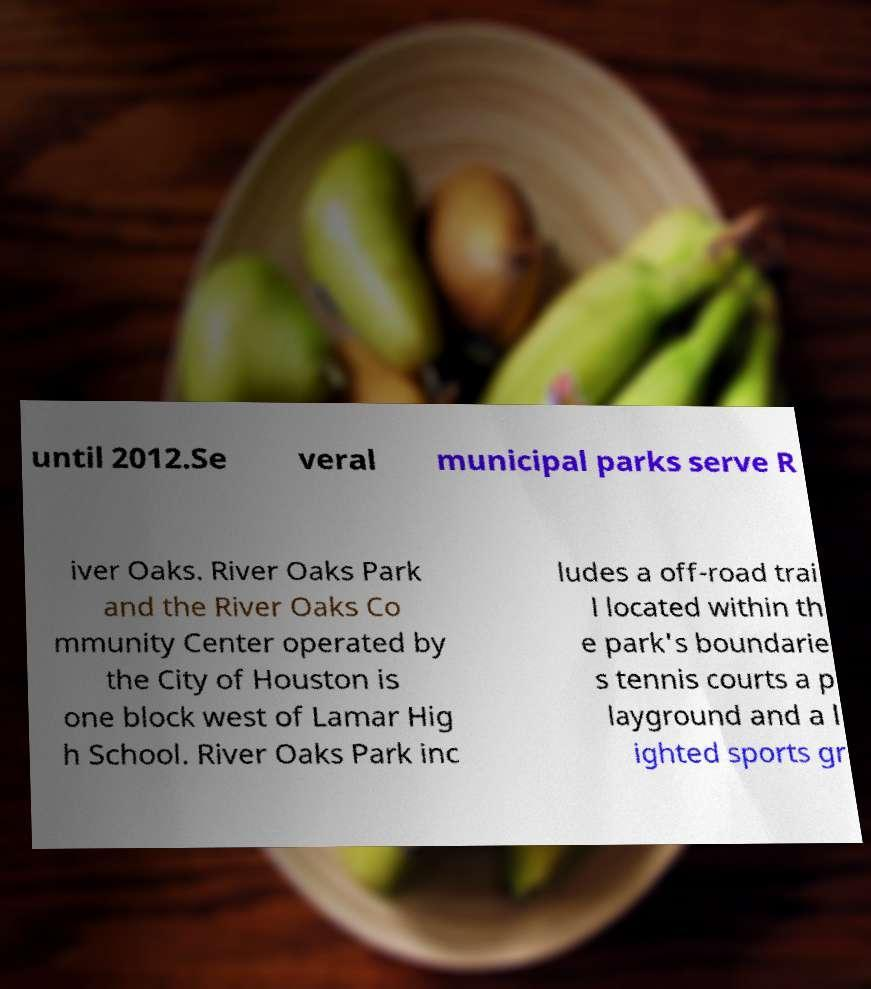I need the written content from this picture converted into text. Can you do that? until 2012.Se veral municipal parks serve R iver Oaks. River Oaks Park and the River Oaks Co mmunity Center operated by the City of Houston is one block west of Lamar Hig h School. River Oaks Park inc ludes a off-road trai l located within th e park's boundarie s tennis courts a p layground and a l ighted sports gr 